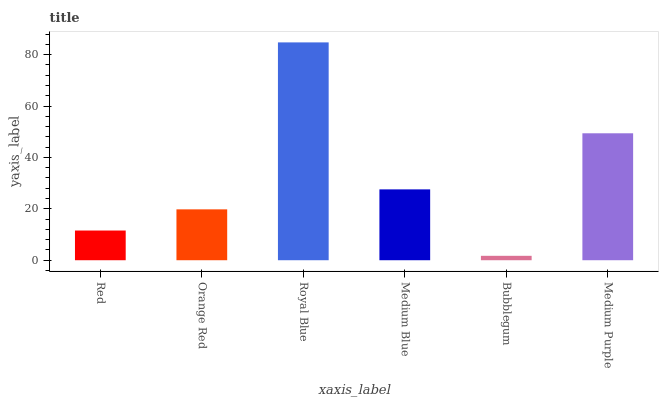Is Bubblegum the minimum?
Answer yes or no. Yes. Is Royal Blue the maximum?
Answer yes or no. Yes. Is Orange Red the minimum?
Answer yes or no. No. Is Orange Red the maximum?
Answer yes or no. No. Is Orange Red greater than Red?
Answer yes or no. Yes. Is Red less than Orange Red?
Answer yes or no. Yes. Is Red greater than Orange Red?
Answer yes or no. No. Is Orange Red less than Red?
Answer yes or no. No. Is Medium Blue the high median?
Answer yes or no. Yes. Is Orange Red the low median?
Answer yes or no. Yes. Is Red the high median?
Answer yes or no. No. Is Bubblegum the low median?
Answer yes or no. No. 